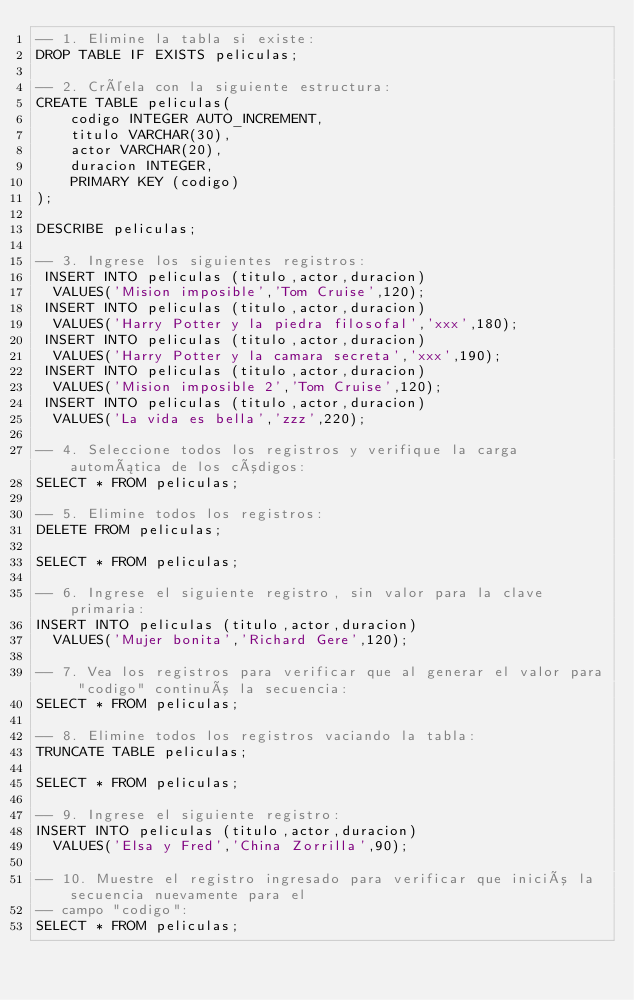<code> <loc_0><loc_0><loc_500><loc_500><_SQL_>-- 1. Elimine la tabla si existe:
DROP TABLE IF EXISTS peliculas;

-- 2. Créela con la siguiente estructura:
CREATE TABLE peliculas(
    codigo INTEGER AUTO_INCREMENT,
    titulo VARCHAR(30),
    actor VARCHAR(20),
    duracion INTEGER,
    PRIMARY KEY (codigo)
);

DESCRIBE peliculas;

-- 3. Ingrese los siguientes registros:
 INSERT INTO peliculas (titulo,actor,duracion)
  VALUES('Mision imposible','Tom Cruise',120);
 INSERT INTO peliculas (titulo,actor,duracion)
  VALUES('Harry Potter y la piedra filosofal','xxx',180);
 INSERT INTO peliculas (titulo,actor,duracion)
  VALUES('Harry Potter y la camara secreta','xxx',190);
 INSERT INTO peliculas (titulo,actor,duracion)
  VALUES('Mision imposible 2','Tom Cruise',120);
 INSERT INTO peliculas (titulo,actor,duracion)
  VALUES('La vida es bella','zzz',220);

-- 4. Seleccione todos los registros y verifique la carga automática de los códigos:
SELECT * FROM peliculas;

-- 5. Elimine todos los registros:
DELETE FROM peliculas;

SELECT * FROM peliculas;

-- 6. Ingrese el siguiente registro, sin valor para la clave primaria:
INSERT INTO peliculas (titulo,actor,duracion)
  VALUES('Mujer bonita','Richard Gere',120);

-- 7. Vea los registros para verificar que al generar el valor para "codigo" continuó la secuencia:
SELECT * FROM peliculas;

-- 8. Elimine todos los registros vaciando la tabla:
TRUNCATE TABLE peliculas;

SELECT * FROM peliculas;

-- 9. Ingrese el siguiente registro:
INSERT INTO peliculas (titulo,actor,duracion)
  VALUES('Elsa y Fred','China Zorrilla',90);

-- 10. Muestre el registro ingresado para verificar que inició la secuencia nuevamente para el 
-- campo "codigo":
SELECT * FROM peliculas;
</code> 